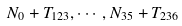Convert formula to latex. <formula><loc_0><loc_0><loc_500><loc_500>N _ { 0 } + T _ { 1 2 3 } , \cdots , N _ { 3 5 } + T _ { 2 3 6 }</formula> 